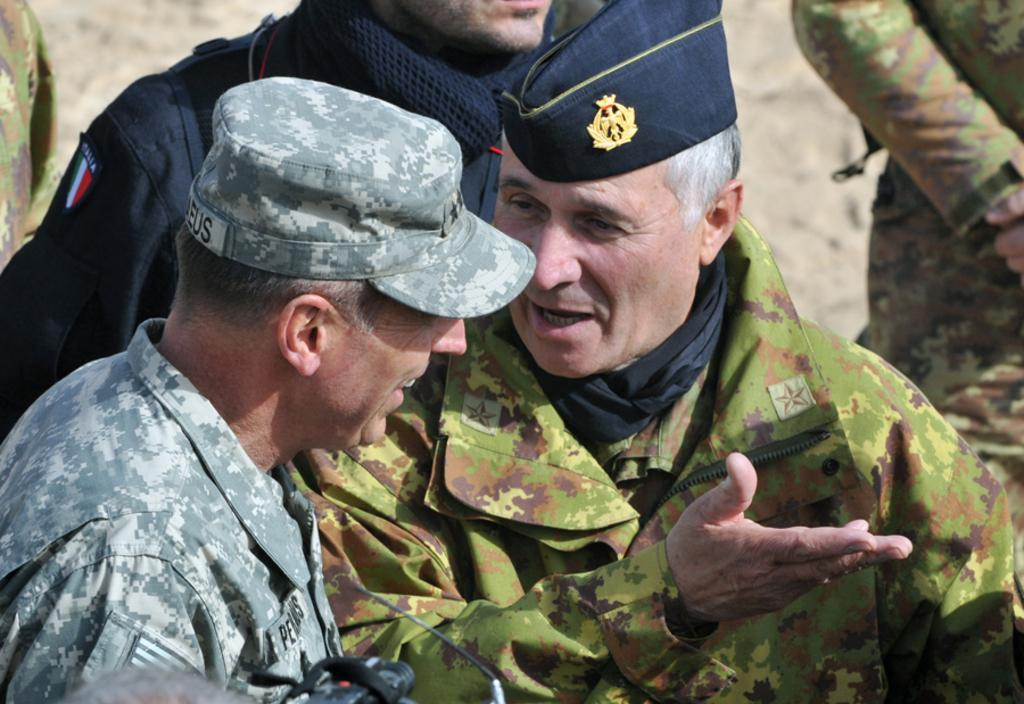What is the main subject of the image? The main subject of the image is a group of people. Can you describe any specific details about the people in the image? Two men in the group are wearing caps. What are the two men with caps doing? The two men are talking. What expressions do the two men have? The two men are smiling. What type of care can be seen being provided to the butter in the image? There is no butter present in the image, so it is not possible to determine if any care is being provided to it. 